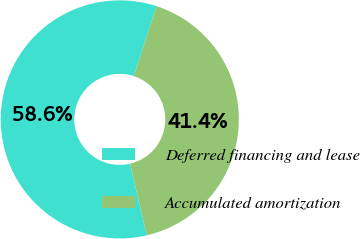Convert chart to OTSL. <chart><loc_0><loc_0><loc_500><loc_500><pie_chart><fcel>Deferred financing and lease<fcel>Accumulated amortization<nl><fcel>58.64%<fcel>41.36%<nl></chart> 